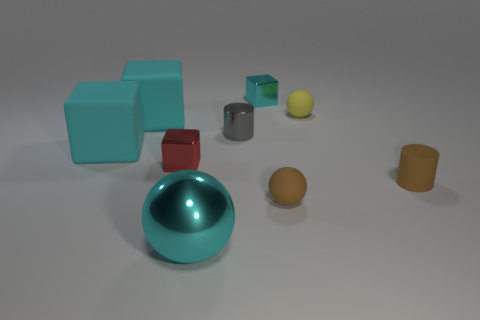The large sphere has what color?
Offer a terse response. Cyan. What is the shape of the brown thing that is the same material as the small brown ball?
Your answer should be very brief. Cylinder. There is a cyan metal thing to the right of the cyan metallic sphere; does it have the same size as the matte cylinder?
Give a very brief answer. Yes. What number of things are big objects that are in front of the small red metal thing or metal objects in front of the tiny cyan metal block?
Your answer should be very brief. 3. There is a tiny cube left of the big metal object; is its color the same as the tiny matte cylinder?
Offer a very short reply. No. How many metal things are either blue balls or large cyan objects?
Offer a terse response. 1. What is the shape of the large shiny thing?
Your answer should be very brief. Sphere. Is there anything else that is made of the same material as the gray object?
Give a very brief answer. Yes. Does the small red block have the same material as the large cyan sphere?
Offer a very short reply. Yes. There is a large cyan object to the right of the metallic block in front of the metal cylinder; are there any matte blocks that are on the left side of it?
Provide a succinct answer. Yes. 